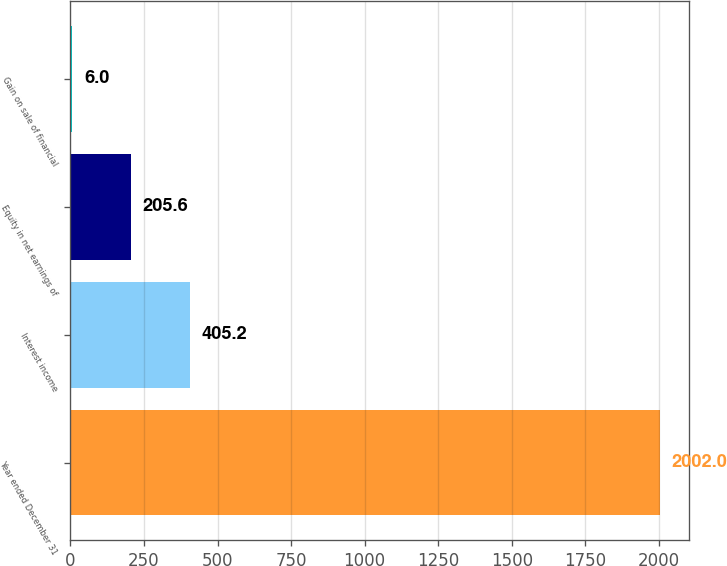Convert chart. <chart><loc_0><loc_0><loc_500><loc_500><bar_chart><fcel>Year ended December 31<fcel>Interest income<fcel>Equity in net earnings of<fcel>Gain on sale of financial<nl><fcel>2002<fcel>405.2<fcel>205.6<fcel>6<nl></chart> 